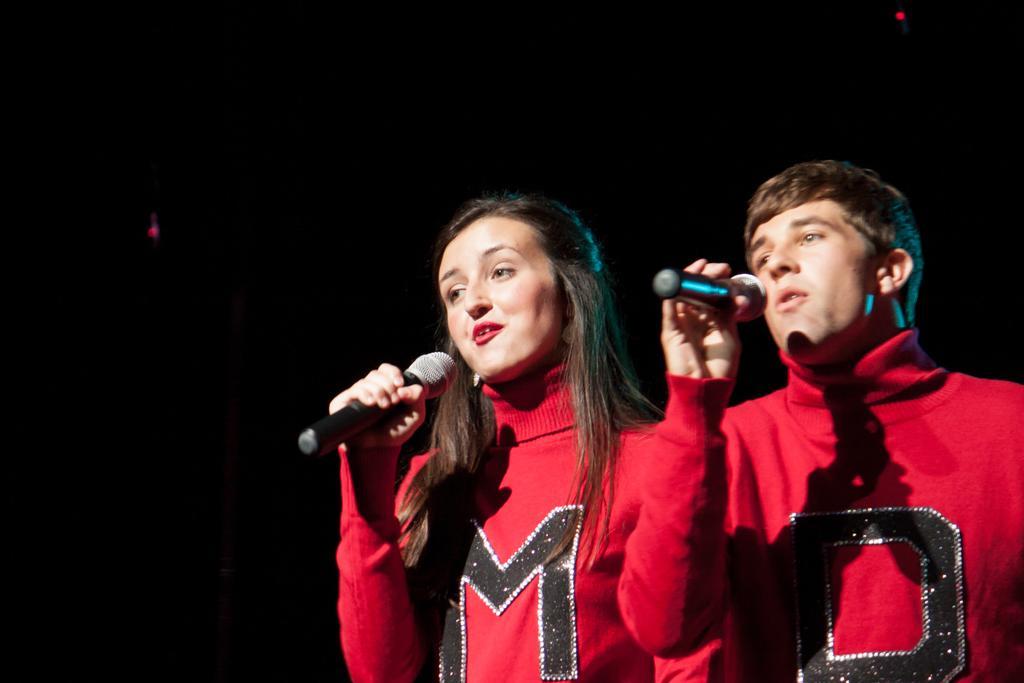Can you describe this image briefly? In this image consist of a two persons wearing a red color jacket and they both are holding a mike and on the left side a woman stand she is open her mouth. 